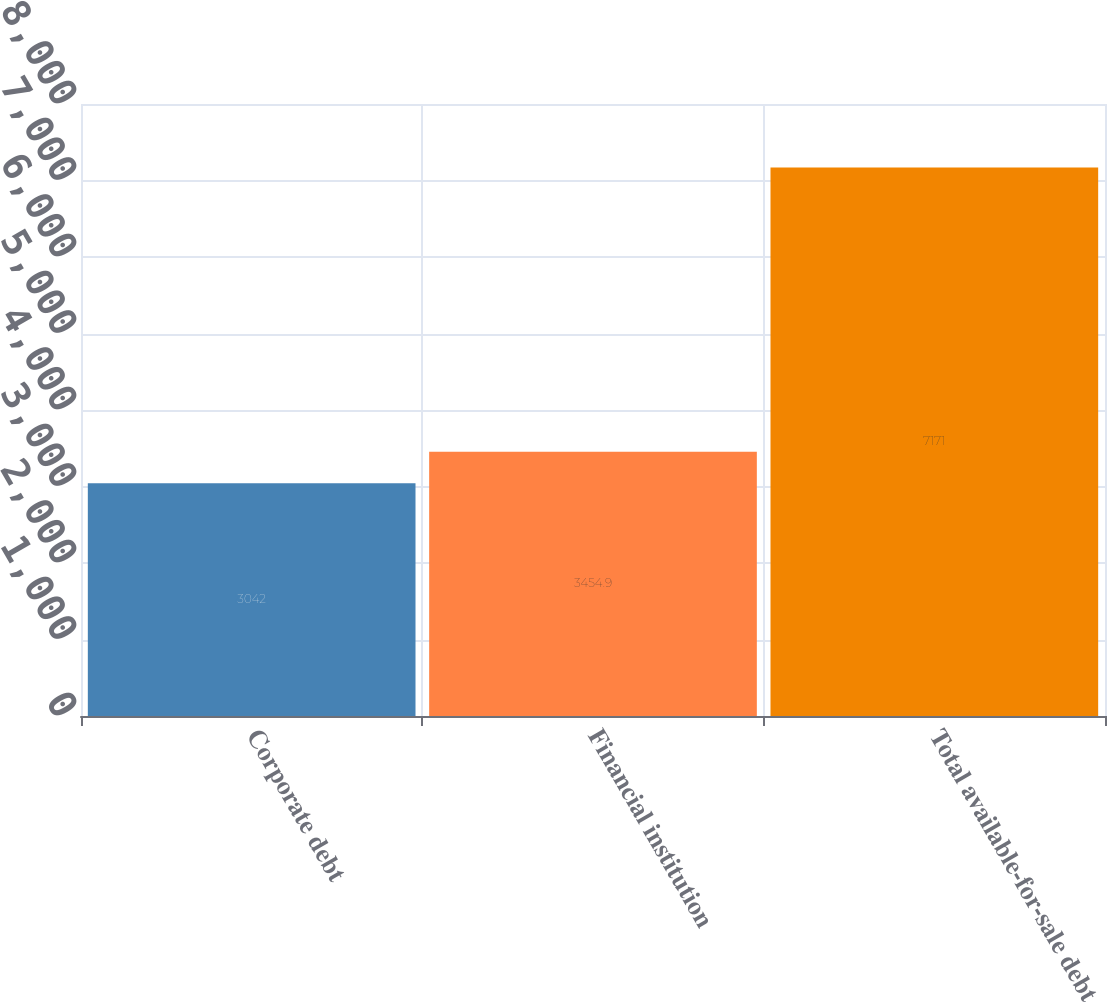<chart> <loc_0><loc_0><loc_500><loc_500><bar_chart><fcel>Corporate debt<fcel>Financial institution<fcel>Total available-for-sale debt<nl><fcel>3042<fcel>3454.9<fcel>7171<nl></chart> 